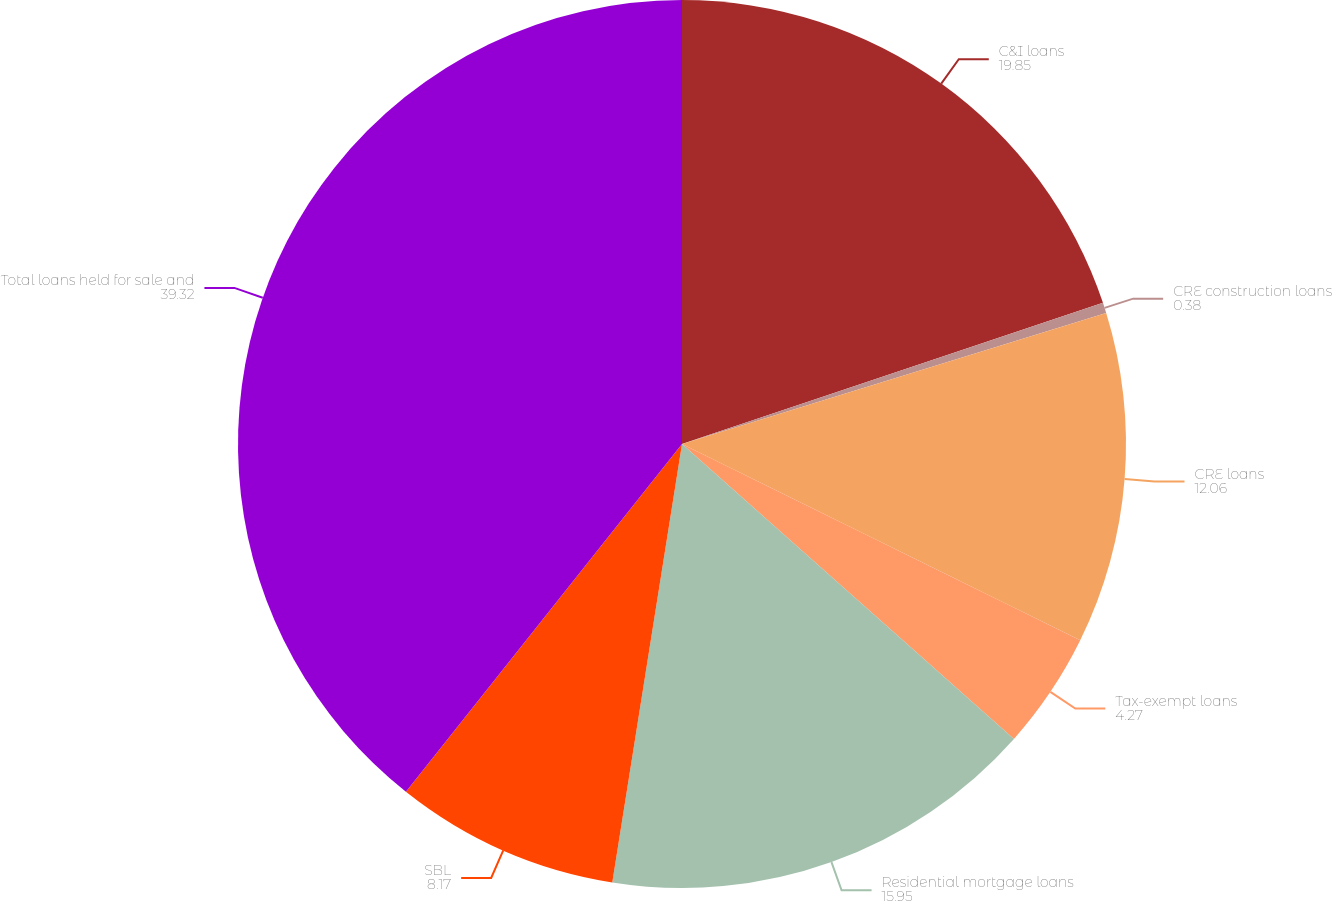<chart> <loc_0><loc_0><loc_500><loc_500><pie_chart><fcel>C&I loans<fcel>CRE construction loans<fcel>CRE loans<fcel>Tax-exempt loans<fcel>Residential mortgage loans<fcel>SBL<fcel>Total loans held for sale and<nl><fcel>19.85%<fcel>0.38%<fcel>12.06%<fcel>4.27%<fcel>15.95%<fcel>8.17%<fcel>39.32%<nl></chart> 